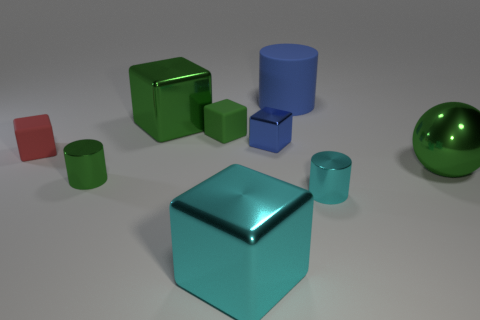Can you tell me about the different textures and finishes of the objects in the image? Certainly, the objects in the image showcase a variety of textures and finishes: the large sphere and the cube in the foreground have a smooth, reflective metallic finish, while the other objects, such as the matte cubes, have a more subdued, non-reflective surface. The contrast in textures emphasizes the differences in materials and adds visual interest to the composition. 